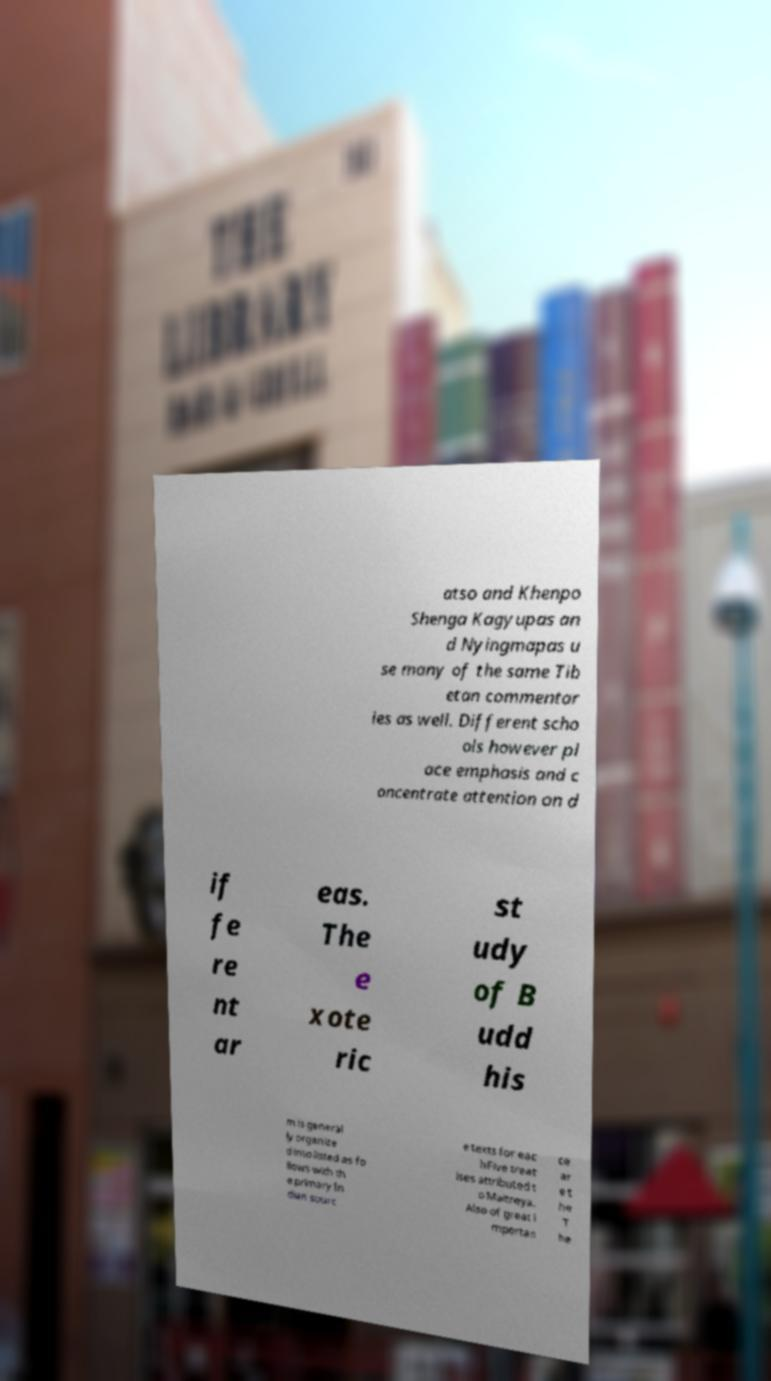For documentation purposes, I need the text within this image transcribed. Could you provide that? atso and Khenpo Shenga Kagyupas an d Nyingmapas u se many of the same Tib etan commentar ies as well. Different scho ols however pl ace emphasis and c oncentrate attention on d if fe re nt ar eas. The e xote ric st udy of B udd his m is general ly organize d into listed as fo llows with th e primary In dian sourc e texts for eac hFive treat ises attributed t o Maitreya. Also of great i mportan ce ar e t he T he 